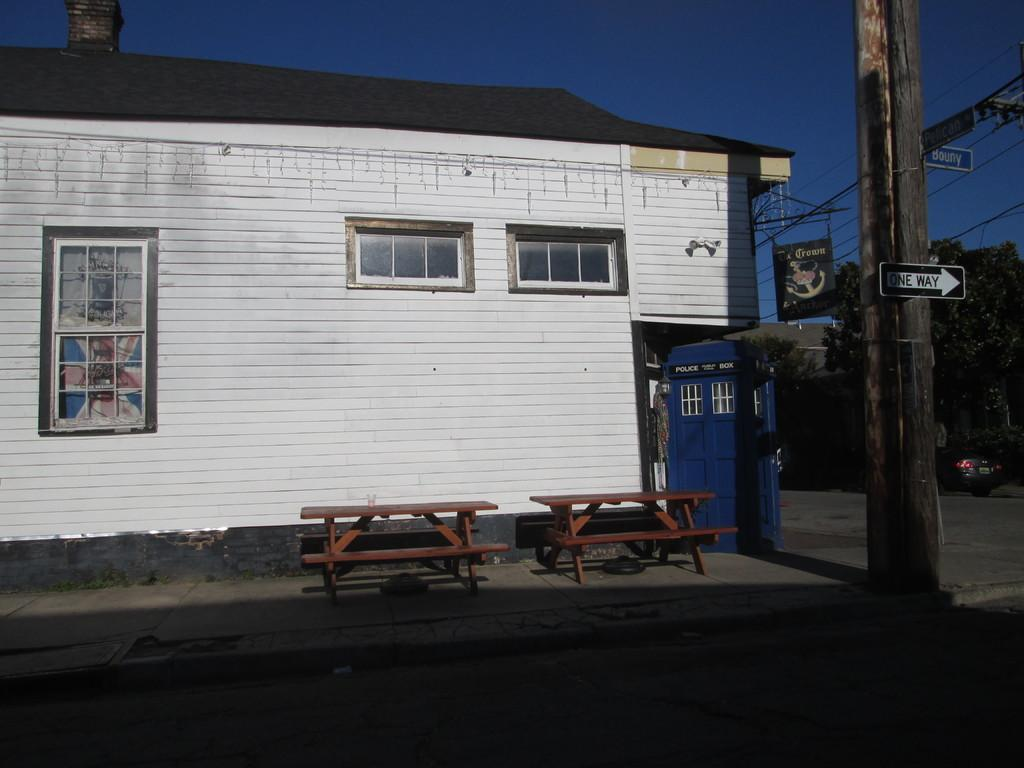What type of structure is present in the image? There is a building in the image. What feature can be observed on the building? The building has windows. What type of seating is available in the image? There are benches in the image. What other object can be seen in the image? There is a pole in the image. What is hanging from the pole? There is a banner in the image. What type of vegetation is present in the image? There are trees in the image. What is visible at the top of the image? The sky is visible at the top of the image. How would you describe the lighting in the image? The image is slightly dark. What type of celery is growing near the building in the image? There is no celery present in the image; it features a building, benches, a pole, a banner, trees, and the sky. 